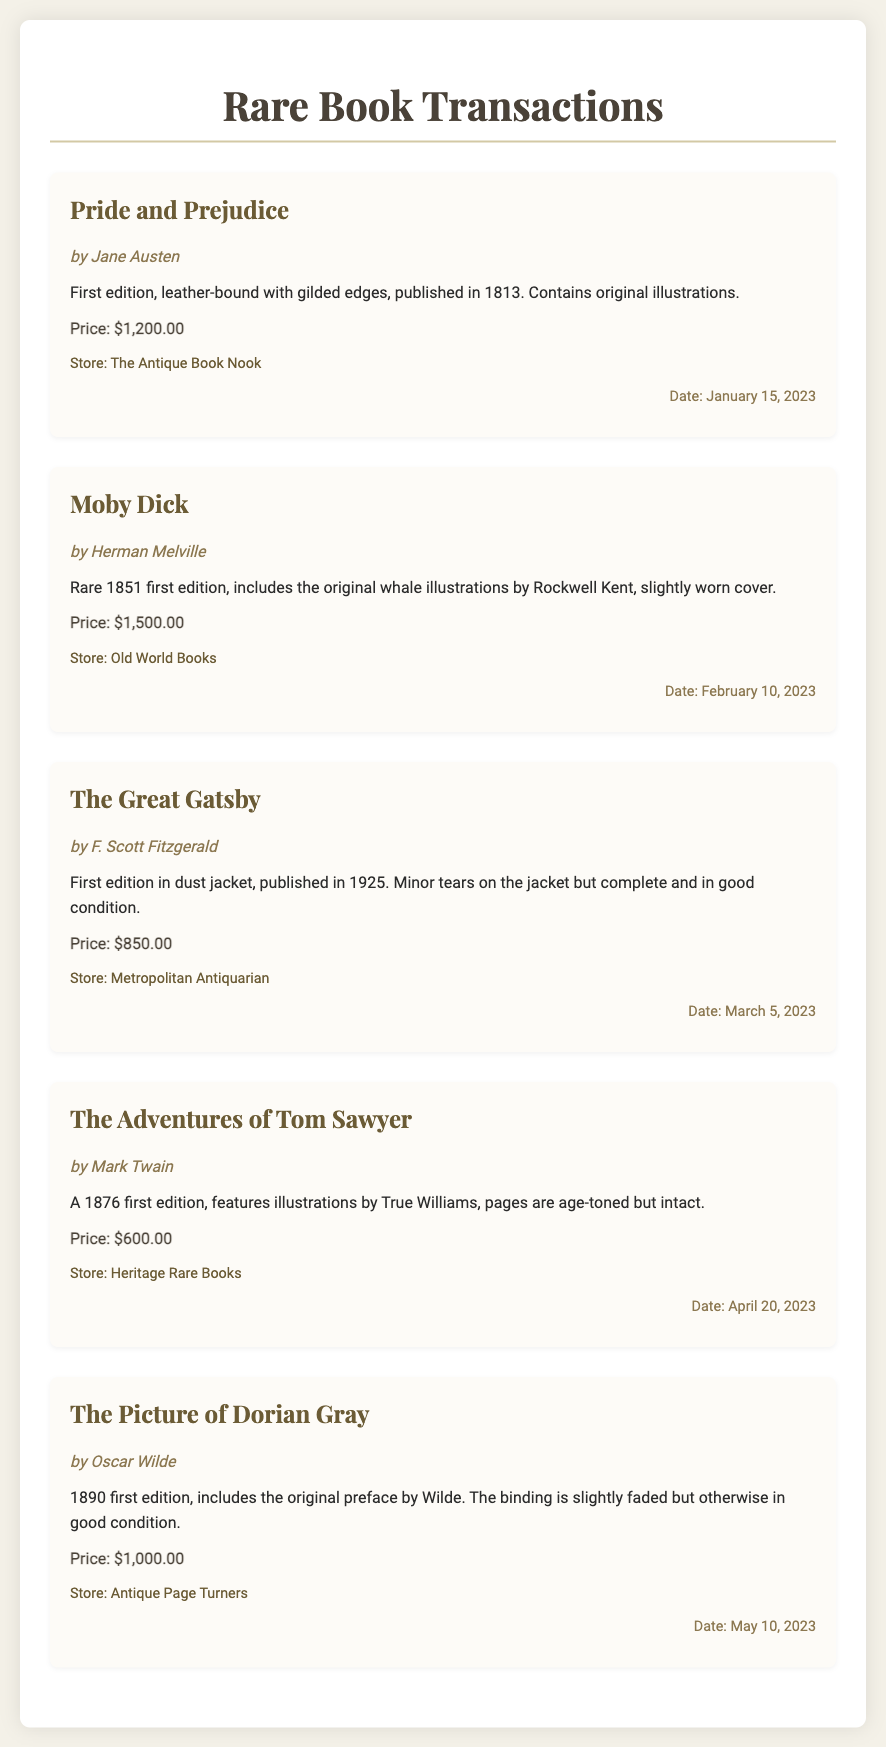What is the title of the first book listed? The first book listed is "Pride and Prejudice."
Answer: Pride and Prejudice Who is the author of "Moby Dick"? The author of "Moby Dick" is Herman Melville.
Answer: Herman Melville What is the price of "The Great Gatsby"? The price of "The Great Gatsby" is specified in the document as $850.00.
Answer: $850.00 When was "The Adventures of Tom Sawyer" purchased? The purchase date for "The Adventures of Tom Sawyer" is mentioned as April 20, 2023.
Answer: April 20, 2023 Which store sold "The Picture of Dorian Gray"? The store mentioned for "The Picture of Dorian Gray" is Antique Page Turners.
Answer: Antique Page Turners What condition description is provided for "The Great Gatsby"? The condition description for "The Great Gatsby" includes "Minor tears on the jacket but complete and in good condition."
Answer: Minor tears on the jacket but complete and in good condition Which book has the highest price? To find the book with the highest price, we compare the prices listed; "Moby Dick" is priced at $1,500.00.
Answer: Moby Dick How many books are listed in the document? The document contains five transactions related to books.
Answer: Five What is the publishing year of "Pride and Prejudice"? The publishing year of "Pride and Prejudice" is 1813, as noted in the description.
Answer: 1813 